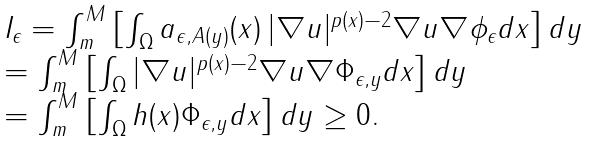<formula> <loc_0><loc_0><loc_500><loc_500>\begin{array} { l } I _ { \epsilon } = \int _ { m } ^ { M } \left [ \int _ { \Omega } a _ { \epsilon , A ( y ) } ( x ) \, | \nabla u | ^ { p ( x ) - 2 } \nabla u \nabla \phi _ { \epsilon } d x \right ] d y \\ = \int _ { m } ^ { M } \left [ \int _ { \Omega } | \nabla u | ^ { p ( x ) - 2 } \nabla u \nabla \Phi _ { \epsilon , y } d x \right ] d y \\ = \int _ { m } ^ { M } \left [ \int _ { \Omega } h ( x ) \Phi _ { \epsilon , y } d x \right ] d y \geq 0 . \end{array}</formula> 